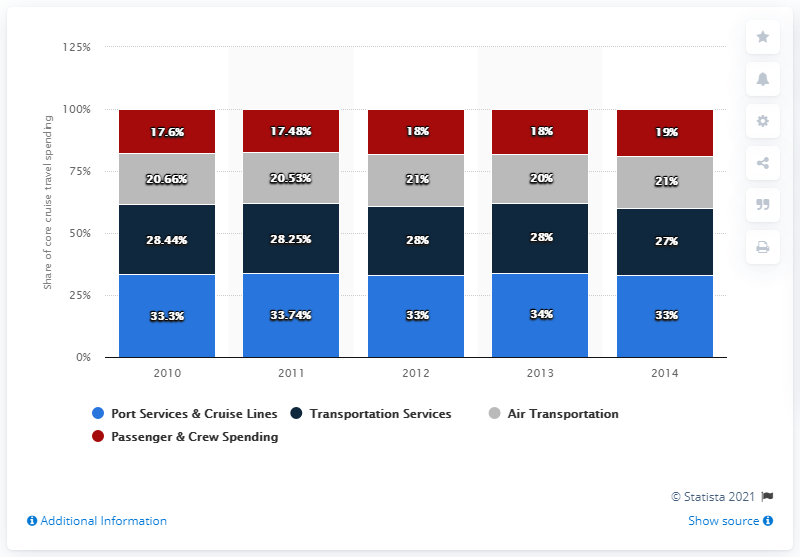Point out several critical features in this image. In the chart provided, the first year is 2010. In 2014 data, by adding the first three data from the top and subtracting the last data, the result is 34... 